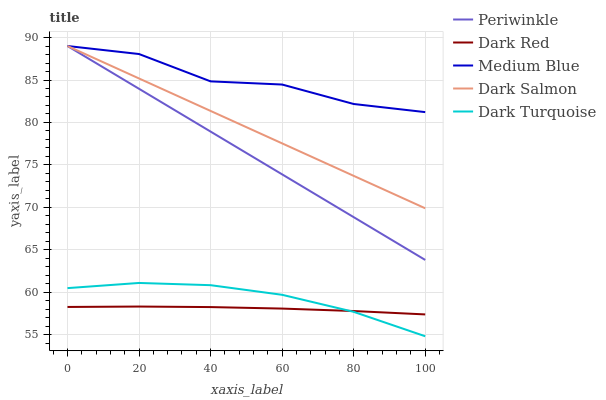Does Dark Red have the minimum area under the curve?
Answer yes or no. Yes. Does Medium Blue have the maximum area under the curve?
Answer yes or no. Yes. Does Periwinkle have the minimum area under the curve?
Answer yes or no. No. Does Periwinkle have the maximum area under the curve?
Answer yes or no. No. Is Periwinkle the smoothest?
Answer yes or no. Yes. Is Medium Blue the roughest?
Answer yes or no. Yes. Is Medium Blue the smoothest?
Answer yes or no. No. Is Periwinkle the roughest?
Answer yes or no. No. Does Periwinkle have the lowest value?
Answer yes or no. No. Does Dark Salmon have the highest value?
Answer yes or no. Yes. Does Dark Turquoise have the highest value?
Answer yes or no. No. Is Dark Turquoise less than Dark Salmon?
Answer yes or no. Yes. Is Medium Blue greater than Dark Turquoise?
Answer yes or no. Yes. Does Dark Turquoise intersect Dark Red?
Answer yes or no. Yes. Is Dark Turquoise less than Dark Red?
Answer yes or no. No. Is Dark Turquoise greater than Dark Red?
Answer yes or no. No. Does Dark Turquoise intersect Dark Salmon?
Answer yes or no. No. 